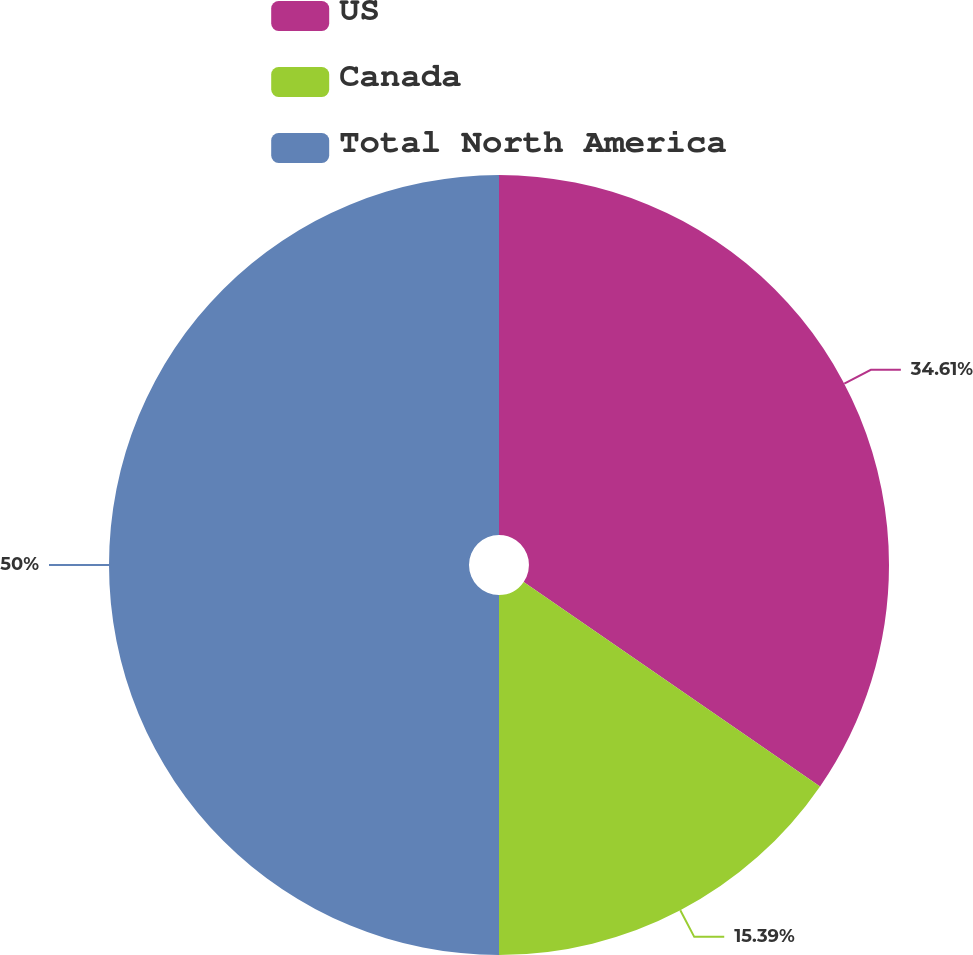Convert chart. <chart><loc_0><loc_0><loc_500><loc_500><pie_chart><fcel>US<fcel>Canada<fcel>Total North America<nl><fcel>34.61%<fcel>15.39%<fcel>50.0%<nl></chart> 